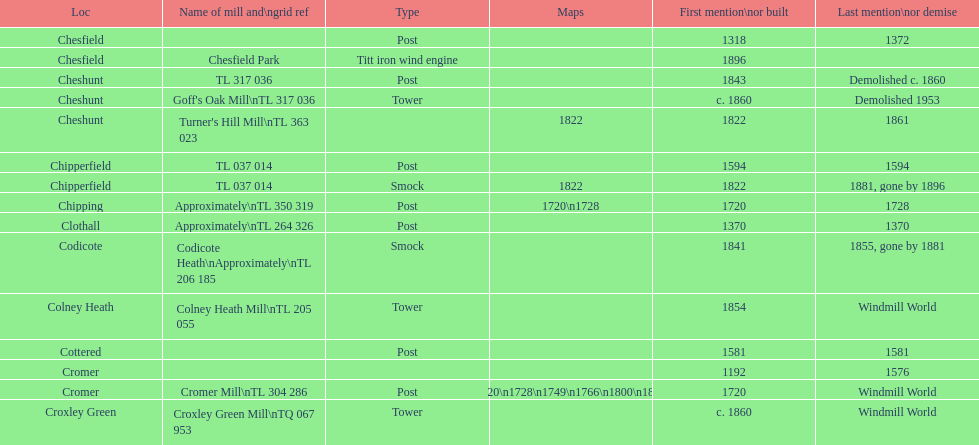How many mills were built or first mentioned after 1800? 8. 